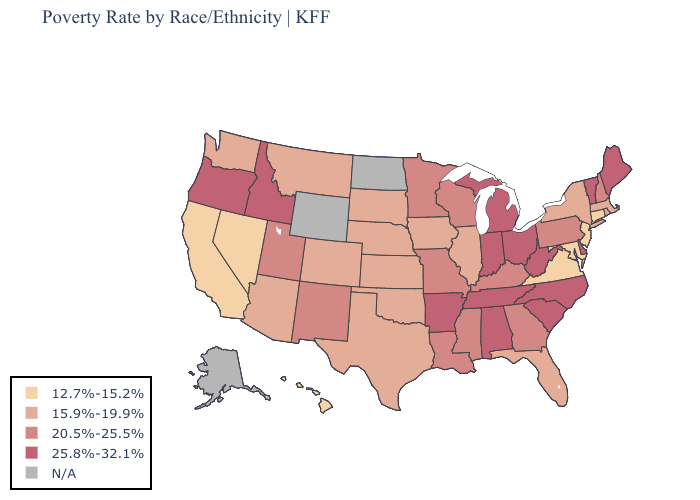Is the legend a continuous bar?
Give a very brief answer. No. Which states have the lowest value in the USA?
Be succinct. California, Connecticut, Hawaii, Maryland, Nevada, New Jersey, Virginia. Name the states that have a value in the range 25.8%-32.1%?
Give a very brief answer. Alabama, Arkansas, Delaware, Idaho, Indiana, Maine, Michigan, North Carolina, Ohio, Oregon, South Carolina, Tennessee, Vermont, West Virginia. Name the states that have a value in the range 12.7%-15.2%?
Quick response, please. California, Connecticut, Hawaii, Maryland, Nevada, New Jersey, Virginia. Does Louisiana have the highest value in the South?
Quick response, please. No. Does Oregon have the highest value in the USA?
Answer briefly. Yes. What is the value of Ohio?
Keep it brief. 25.8%-32.1%. Does the first symbol in the legend represent the smallest category?
Answer briefly. Yes. What is the value of Georgia?
Answer briefly. 20.5%-25.5%. Name the states that have a value in the range N/A?
Write a very short answer. Alaska, North Dakota, Wyoming. Among the states that border Connecticut , which have the lowest value?
Answer briefly. Massachusetts, New York, Rhode Island. Name the states that have a value in the range 25.8%-32.1%?
Quick response, please. Alabama, Arkansas, Delaware, Idaho, Indiana, Maine, Michigan, North Carolina, Ohio, Oregon, South Carolina, Tennessee, Vermont, West Virginia. Which states hav the highest value in the Northeast?
Quick response, please. Maine, Vermont. Among the states that border Washington , which have the highest value?
Be succinct. Idaho, Oregon. 